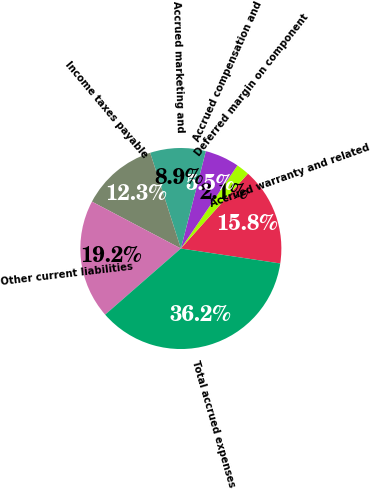<chart> <loc_0><loc_0><loc_500><loc_500><pie_chart><fcel>Accrued warranty and related<fcel>Deferred margin on component<fcel>Accrued compensation and<fcel>Accrued marketing and<fcel>Income taxes payable<fcel>Other current liabilities<fcel>Total accrued expenses<nl><fcel>15.75%<fcel>2.11%<fcel>5.52%<fcel>8.93%<fcel>12.34%<fcel>19.15%<fcel>36.19%<nl></chart> 